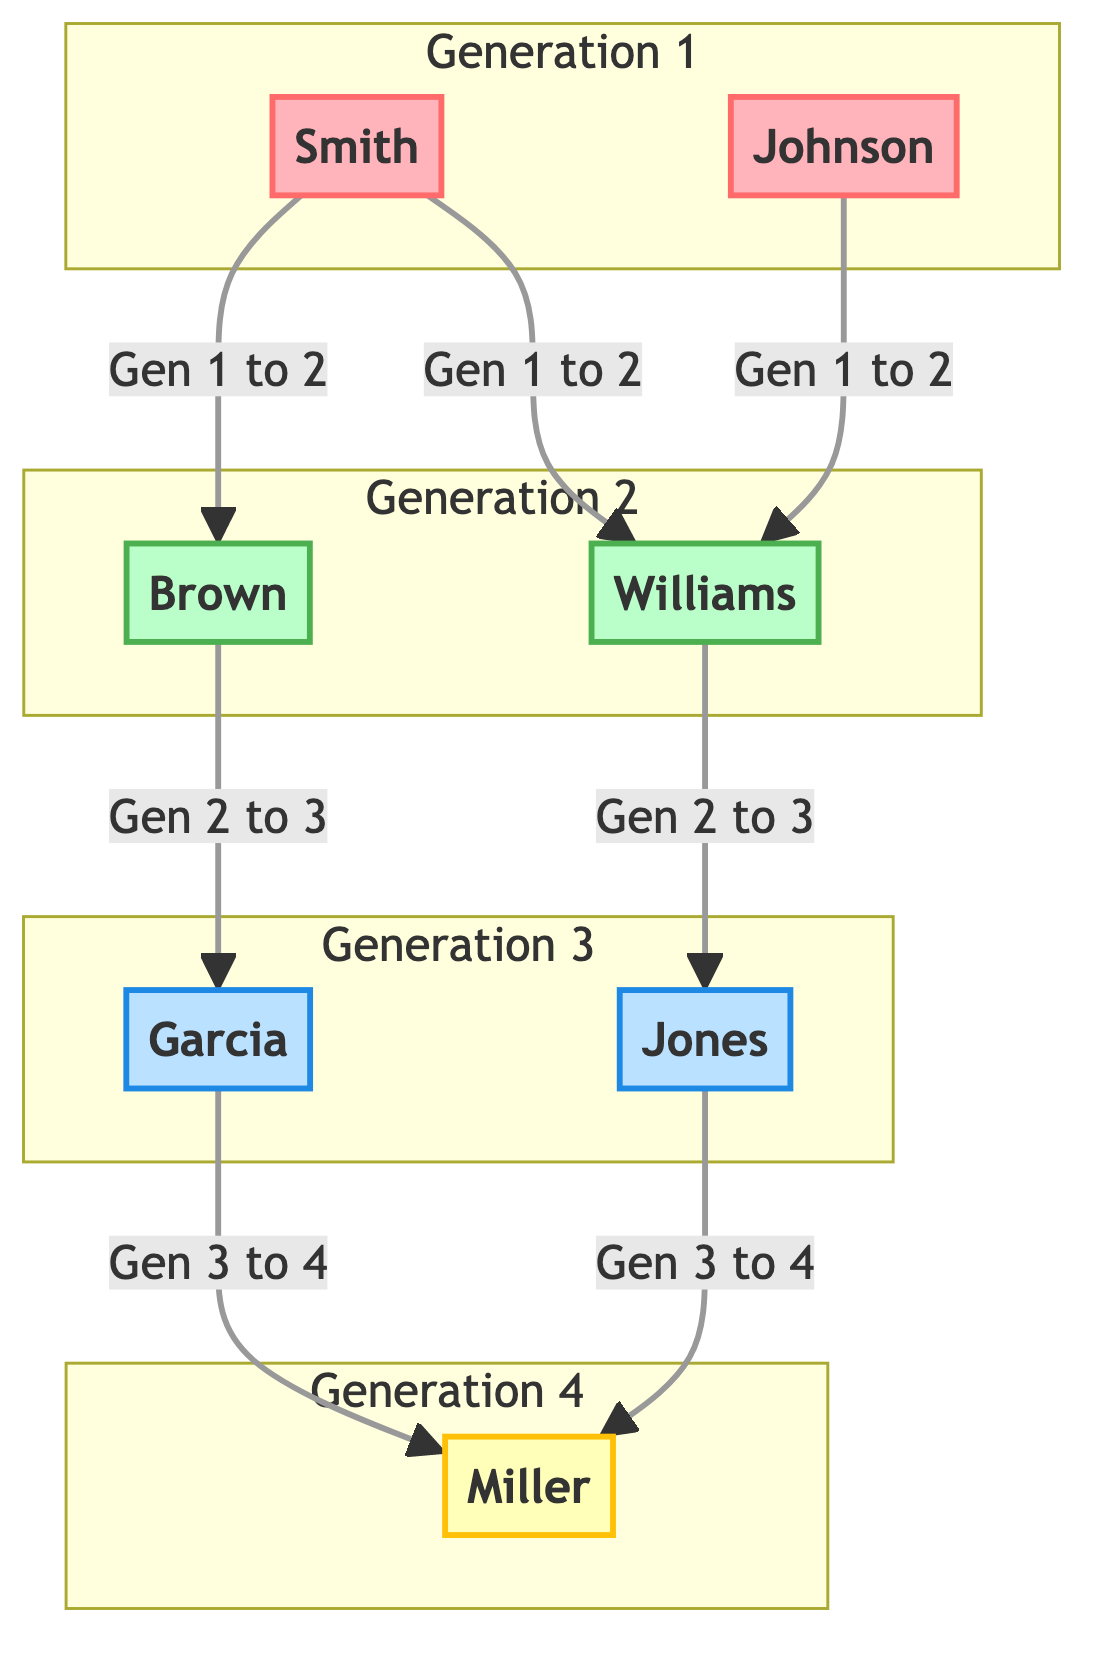What are the names in Generation 1? The diagram shows two nodes in Generation 1: "Smith" and "Johnson". These are the first generation names listed.
Answer: Smith, Johnson How many edges are there in the diagram? By counting the lines connecting the nodes, we find there are 6 edges connecting various generations.
Answer: 6 Who are the parents of Williams? Referring to the edges leading to the node labeled "Williams", we see it connects to "Smith" and "Johnson". Thus, they are his parents.
Answer: Smith, Johnson What is the generation of the Miller family name? The node labeled "Miller" is located in Generation 4, which is clearly indicated in the diagram's generational classification.
Answer: 4 Which names are connected to the name "Jones"? Following the edges from "Jones", we see that it leads to "Miller", indicating that "Miller" is the child of "Jones".
Answer: Miller How many names are in Generation 3? The diagram shows two names in Generation 3: "Jones" and "Garcia". Thus, we can count them to find the total.
Answer: 2 What connection exists between "Brown" and "Miller"? To find the relationship between "Brown" and "Miller", we trace the edges from "Brown" to "Garcia" and from "Jones" to "Miller"; thus, "Brown" is a grandparent of "Miller".
Answer: Grandparent Are there any names with the same generation as "Williams"? The node labeled "Williams" is in Generation 2, which includes "Williams" and "Brown", showing two connections at this level.
Answer: Brown 